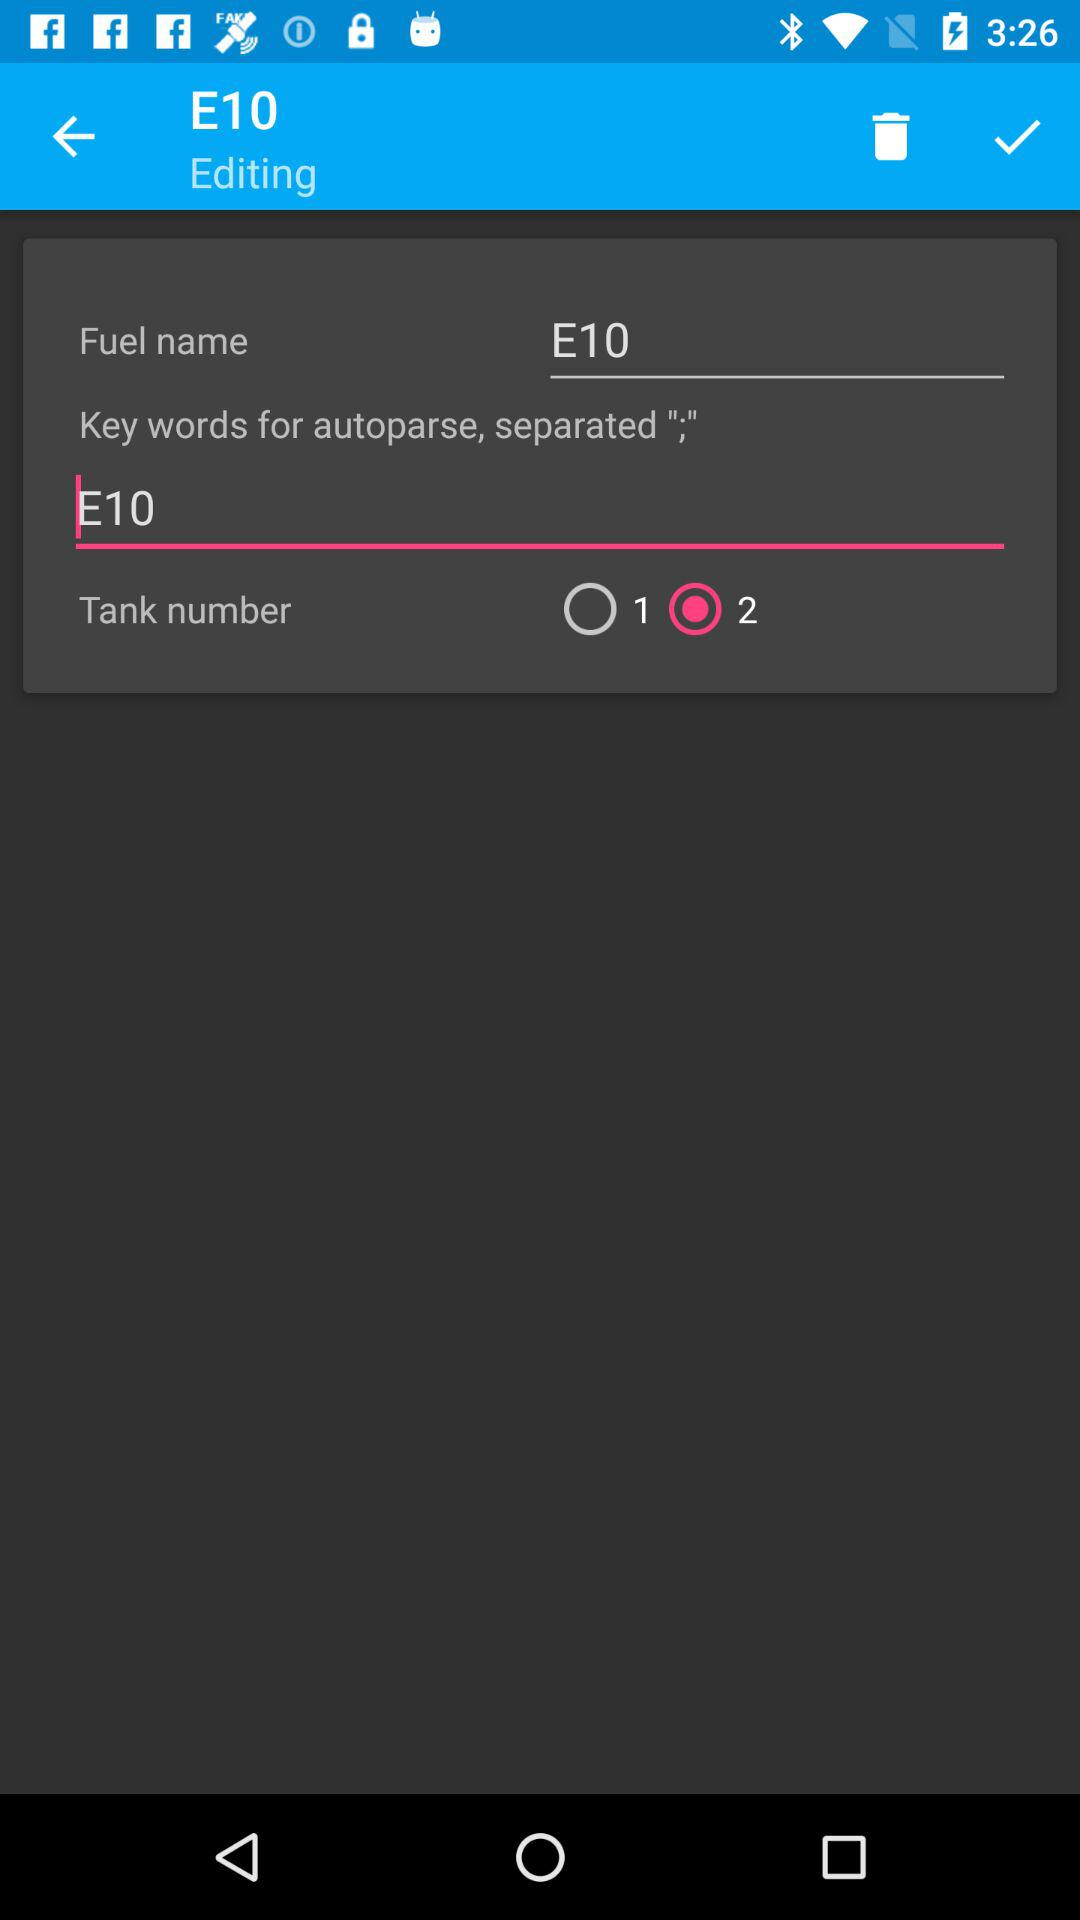What tank number is selected? The selected tank number is 2. 